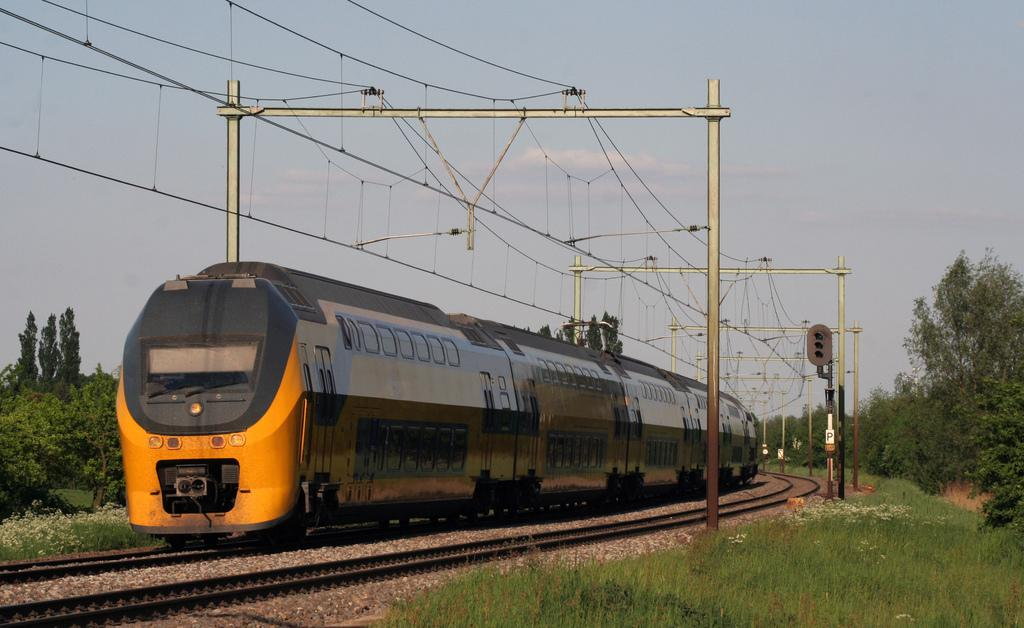What is the main subject of the image? There is a yellow locomotive in the image. What is the locomotive doing in the image? The locomotive is moving on a track. What can be seen in the background of the image? There are trees, wires, and the sky visible in the background of the image. What type of cord is being used to control the movement of the locomotive in the image? There is no cord visible in the image, and the locomotive's movement is not controlled by a cord. Are there any mittens present in the image? There are no mittens visible in the image. 